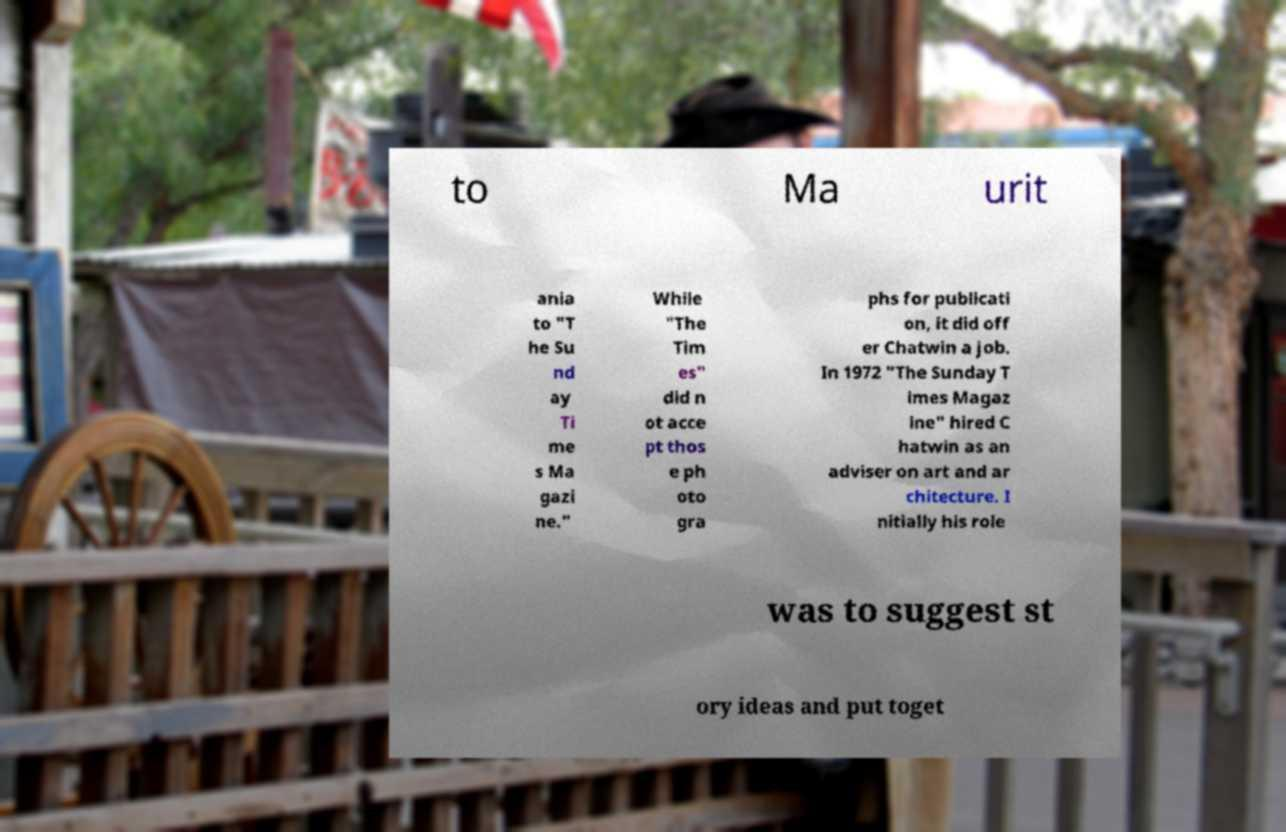Please identify and transcribe the text found in this image. to Ma urit ania to "T he Su nd ay Ti me s Ma gazi ne." While "The Tim es" did n ot acce pt thos e ph oto gra phs for publicati on, it did off er Chatwin a job. In 1972 "The Sunday T imes Magaz ine" hired C hatwin as an adviser on art and ar chitecture. I nitially his role was to suggest st ory ideas and put toget 